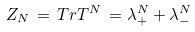Convert formula to latex. <formula><loc_0><loc_0><loc_500><loc_500>Z _ { N } \, = \, T r T ^ { N } \, = \lambda _ { + } ^ { N } + \lambda _ { - } ^ { N }</formula> 